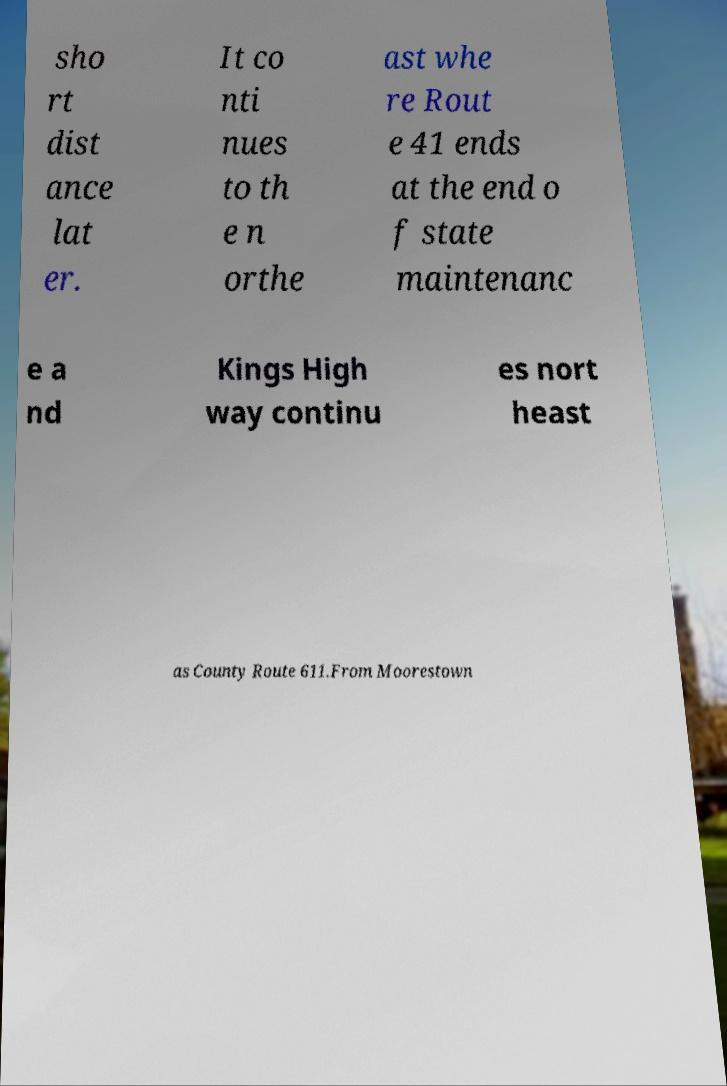Can you accurately transcribe the text from the provided image for me? sho rt dist ance lat er. It co nti nues to th e n orthe ast whe re Rout e 41 ends at the end o f state maintenanc e a nd Kings High way continu es nort heast as County Route 611.From Moorestown 